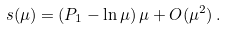Convert formula to latex. <formula><loc_0><loc_0><loc_500><loc_500>s ( \mu ) = ( P _ { 1 } - \ln \mu ) \, \mu + O ( \mu ^ { 2 } ) \, .</formula> 